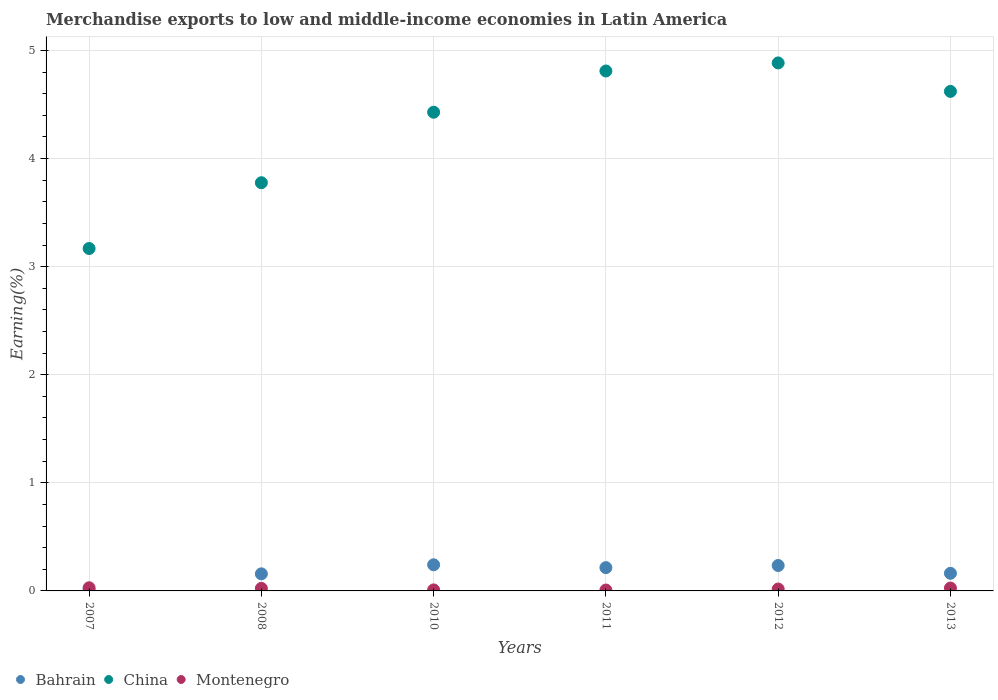What is the percentage of amount earned from merchandise exports in China in 2013?
Your answer should be very brief. 4.62. Across all years, what is the maximum percentage of amount earned from merchandise exports in China?
Make the answer very short. 4.88. Across all years, what is the minimum percentage of amount earned from merchandise exports in China?
Offer a terse response. 3.17. What is the total percentage of amount earned from merchandise exports in China in the graph?
Provide a short and direct response. 25.69. What is the difference between the percentage of amount earned from merchandise exports in Montenegro in 2010 and that in 2011?
Offer a terse response. 0. What is the difference between the percentage of amount earned from merchandise exports in Montenegro in 2011 and the percentage of amount earned from merchandise exports in Bahrain in 2013?
Provide a short and direct response. -0.15. What is the average percentage of amount earned from merchandise exports in Montenegro per year?
Offer a very short reply. 0.02. In the year 2011, what is the difference between the percentage of amount earned from merchandise exports in Montenegro and percentage of amount earned from merchandise exports in China?
Offer a very short reply. -4.8. What is the ratio of the percentage of amount earned from merchandise exports in China in 2008 to that in 2012?
Provide a short and direct response. 0.77. What is the difference between the highest and the second highest percentage of amount earned from merchandise exports in Bahrain?
Provide a short and direct response. 0.01. What is the difference between the highest and the lowest percentage of amount earned from merchandise exports in Bahrain?
Your answer should be compact. 0.23. In how many years, is the percentage of amount earned from merchandise exports in China greater than the average percentage of amount earned from merchandise exports in China taken over all years?
Give a very brief answer. 4. Is the sum of the percentage of amount earned from merchandise exports in China in 2007 and 2011 greater than the maximum percentage of amount earned from merchandise exports in Bahrain across all years?
Provide a short and direct response. Yes. Does the percentage of amount earned from merchandise exports in Montenegro monotonically increase over the years?
Provide a short and direct response. No. Is the percentage of amount earned from merchandise exports in China strictly less than the percentage of amount earned from merchandise exports in Bahrain over the years?
Ensure brevity in your answer.  No. How many years are there in the graph?
Your answer should be very brief. 6. What is the difference between two consecutive major ticks on the Y-axis?
Your response must be concise. 1. Does the graph contain grids?
Ensure brevity in your answer.  Yes. How many legend labels are there?
Offer a terse response. 3. How are the legend labels stacked?
Your answer should be compact. Horizontal. What is the title of the graph?
Your answer should be very brief. Merchandise exports to low and middle-income economies in Latin America. Does "Israel" appear as one of the legend labels in the graph?
Offer a terse response. No. What is the label or title of the X-axis?
Your response must be concise. Years. What is the label or title of the Y-axis?
Keep it short and to the point. Earning(%). What is the Earning(%) of Bahrain in 2007?
Give a very brief answer. 0.01. What is the Earning(%) of China in 2007?
Keep it short and to the point. 3.17. What is the Earning(%) of Montenegro in 2007?
Offer a very short reply. 0.03. What is the Earning(%) of Bahrain in 2008?
Offer a terse response. 0.16. What is the Earning(%) in China in 2008?
Keep it short and to the point. 3.78. What is the Earning(%) of Montenegro in 2008?
Ensure brevity in your answer.  0.02. What is the Earning(%) in Bahrain in 2010?
Provide a short and direct response. 0.24. What is the Earning(%) in China in 2010?
Keep it short and to the point. 4.43. What is the Earning(%) of Montenegro in 2010?
Offer a terse response. 0.01. What is the Earning(%) of Bahrain in 2011?
Give a very brief answer. 0.22. What is the Earning(%) in China in 2011?
Keep it short and to the point. 4.81. What is the Earning(%) in Montenegro in 2011?
Your answer should be very brief. 0.01. What is the Earning(%) in Bahrain in 2012?
Make the answer very short. 0.24. What is the Earning(%) in China in 2012?
Your answer should be compact. 4.88. What is the Earning(%) in Montenegro in 2012?
Your response must be concise. 0.02. What is the Earning(%) of Bahrain in 2013?
Your answer should be very brief. 0.16. What is the Earning(%) of China in 2013?
Provide a short and direct response. 4.62. What is the Earning(%) in Montenegro in 2013?
Provide a succinct answer. 0.03. Across all years, what is the maximum Earning(%) in Bahrain?
Offer a very short reply. 0.24. Across all years, what is the maximum Earning(%) in China?
Make the answer very short. 4.88. Across all years, what is the maximum Earning(%) in Montenegro?
Provide a short and direct response. 0.03. Across all years, what is the minimum Earning(%) in Bahrain?
Make the answer very short. 0.01. Across all years, what is the minimum Earning(%) of China?
Give a very brief answer. 3.17. Across all years, what is the minimum Earning(%) in Montenegro?
Give a very brief answer. 0.01. What is the total Earning(%) of Bahrain in the graph?
Ensure brevity in your answer.  1.02. What is the total Earning(%) of China in the graph?
Offer a terse response. 25.69. What is the total Earning(%) in Montenegro in the graph?
Ensure brevity in your answer.  0.11. What is the difference between the Earning(%) in Bahrain in 2007 and that in 2008?
Provide a succinct answer. -0.15. What is the difference between the Earning(%) of China in 2007 and that in 2008?
Your answer should be very brief. -0.61. What is the difference between the Earning(%) in Montenegro in 2007 and that in 2008?
Your response must be concise. 0.01. What is the difference between the Earning(%) in Bahrain in 2007 and that in 2010?
Give a very brief answer. -0.23. What is the difference between the Earning(%) in China in 2007 and that in 2010?
Your answer should be very brief. -1.26. What is the difference between the Earning(%) of Montenegro in 2007 and that in 2010?
Give a very brief answer. 0.02. What is the difference between the Earning(%) in Bahrain in 2007 and that in 2011?
Your response must be concise. -0.21. What is the difference between the Earning(%) of China in 2007 and that in 2011?
Make the answer very short. -1.64. What is the difference between the Earning(%) of Montenegro in 2007 and that in 2011?
Ensure brevity in your answer.  0.02. What is the difference between the Earning(%) of Bahrain in 2007 and that in 2012?
Provide a succinct answer. -0.23. What is the difference between the Earning(%) of China in 2007 and that in 2012?
Give a very brief answer. -1.72. What is the difference between the Earning(%) in Montenegro in 2007 and that in 2012?
Offer a terse response. 0.01. What is the difference between the Earning(%) in Bahrain in 2007 and that in 2013?
Offer a terse response. -0.15. What is the difference between the Earning(%) of China in 2007 and that in 2013?
Ensure brevity in your answer.  -1.45. What is the difference between the Earning(%) in Montenegro in 2007 and that in 2013?
Offer a very short reply. 0. What is the difference between the Earning(%) of Bahrain in 2008 and that in 2010?
Keep it short and to the point. -0.08. What is the difference between the Earning(%) of China in 2008 and that in 2010?
Make the answer very short. -0.65. What is the difference between the Earning(%) in Montenegro in 2008 and that in 2010?
Provide a short and direct response. 0.01. What is the difference between the Earning(%) of Bahrain in 2008 and that in 2011?
Keep it short and to the point. -0.06. What is the difference between the Earning(%) in China in 2008 and that in 2011?
Provide a short and direct response. -1.03. What is the difference between the Earning(%) of Montenegro in 2008 and that in 2011?
Keep it short and to the point. 0.02. What is the difference between the Earning(%) of Bahrain in 2008 and that in 2012?
Ensure brevity in your answer.  -0.08. What is the difference between the Earning(%) of China in 2008 and that in 2012?
Make the answer very short. -1.11. What is the difference between the Earning(%) in Montenegro in 2008 and that in 2012?
Offer a terse response. 0.01. What is the difference between the Earning(%) in Bahrain in 2008 and that in 2013?
Provide a succinct answer. -0.01. What is the difference between the Earning(%) in China in 2008 and that in 2013?
Offer a terse response. -0.84. What is the difference between the Earning(%) in Montenegro in 2008 and that in 2013?
Your answer should be compact. -0. What is the difference between the Earning(%) of Bahrain in 2010 and that in 2011?
Keep it short and to the point. 0.03. What is the difference between the Earning(%) of China in 2010 and that in 2011?
Make the answer very short. -0.38. What is the difference between the Earning(%) in Montenegro in 2010 and that in 2011?
Offer a terse response. 0. What is the difference between the Earning(%) of Bahrain in 2010 and that in 2012?
Provide a short and direct response. 0.01. What is the difference between the Earning(%) of China in 2010 and that in 2012?
Your answer should be very brief. -0.46. What is the difference between the Earning(%) in Montenegro in 2010 and that in 2012?
Give a very brief answer. -0.01. What is the difference between the Earning(%) of Bahrain in 2010 and that in 2013?
Offer a terse response. 0.08. What is the difference between the Earning(%) of China in 2010 and that in 2013?
Keep it short and to the point. -0.19. What is the difference between the Earning(%) of Montenegro in 2010 and that in 2013?
Your answer should be very brief. -0.02. What is the difference between the Earning(%) in Bahrain in 2011 and that in 2012?
Keep it short and to the point. -0.02. What is the difference between the Earning(%) in China in 2011 and that in 2012?
Provide a short and direct response. -0.07. What is the difference between the Earning(%) in Montenegro in 2011 and that in 2012?
Your answer should be very brief. -0.01. What is the difference between the Earning(%) in Bahrain in 2011 and that in 2013?
Give a very brief answer. 0.05. What is the difference between the Earning(%) in China in 2011 and that in 2013?
Ensure brevity in your answer.  0.19. What is the difference between the Earning(%) in Montenegro in 2011 and that in 2013?
Make the answer very short. -0.02. What is the difference between the Earning(%) in Bahrain in 2012 and that in 2013?
Offer a very short reply. 0.07. What is the difference between the Earning(%) of China in 2012 and that in 2013?
Offer a terse response. 0.26. What is the difference between the Earning(%) in Montenegro in 2012 and that in 2013?
Offer a very short reply. -0.01. What is the difference between the Earning(%) in Bahrain in 2007 and the Earning(%) in China in 2008?
Your answer should be very brief. -3.77. What is the difference between the Earning(%) in Bahrain in 2007 and the Earning(%) in Montenegro in 2008?
Make the answer very short. -0.02. What is the difference between the Earning(%) in China in 2007 and the Earning(%) in Montenegro in 2008?
Your answer should be compact. 3.14. What is the difference between the Earning(%) of Bahrain in 2007 and the Earning(%) of China in 2010?
Offer a very short reply. -4.42. What is the difference between the Earning(%) in Bahrain in 2007 and the Earning(%) in Montenegro in 2010?
Your response must be concise. -0. What is the difference between the Earning(%) in China in 2007 and the Earning(%) in Montenegro in 2010?
Ensure brevity in your answer.  3.16. What is the difference between the Earning(%) in Bahrain in 2007 and the Earning(%) in China in 2011?
Give a very brief answer. -4.8. What is the difference between the Earning(%) of Bahrain in 2007 and the Earning(%) of Montenegro in 2011?
Your response must be concise. -0. What is the difference between the Earning(%) in China in 2007 and the Earning(%) in Montenegro in 2011?
Offer a terse response. 3.16. What is the difference between the Earning(%) in Bahrain in 2007 and the Earning(%) in China in 2012?
Provide a short and direct response. -4.88. What is the difference between the Earning(%) of Bahrain in 2007 and the Earning(%) of Montenegro in 2012?
Keep it short and to the point. -0.01. What is the difference between the Earning(%) of China in 2007 and the Earning(%) of Montenegro in 2012?
Your answer should be very brief. 3.15. What is the difference between the Earning(%) in Bahrain in 2007 and the Earning(%) in China in 2013?
Offer a very short reply. -4.61. What is the difference between the Earning(%) in Bahrain in 2007 and the Earning(%) in Montenegro in 2013?
Give a very brief answer. -0.02. What is the difference between the Earning(%) of China in 2007 and the Earning(%) of Montenegro in 2013?
Your response must be concise. 3.14. What is the difference between the Earning(%) of Bahrain in 2008 and the Earning(%) of China in 2010?
Provide a short and direct response. -4.27. What is the difference between the Earning(%) in Bahrain in 2008 and the Earning(%) in Montenegro in 2010?
Provide a succinct answer. 0.15. What is the difference between the Earning(%) in China in 2008 and the Earning(%) in Montenegro in 2010?
Offer a very short reply. 3.77. What is the difference between the Earning(%) of Bahrain in 2008 and the Earning(%) of China in 2011?
Ensure brevity in your answer.  -4.65. What is the difference between the Earning(%) of Bahrain in 2008 and the Earning(%) of Montenegro in 2011?
Provide a succinct answer. 0.15. What is the difference between the Earning(%) in China in 2008 and the Earning(%) in Montenegro in 2011?
Offer a terse response. 3.77. What is the difference between the Earning(%) in Bahrain in 2008 and the Earning(%) in China in 2012?
Make the answer very short. -4.73. What is the difference between the Earning(%) of Bahrain in 2008 and the Earning(%) of Montenegro in 2012?
Your answer should be compact. 0.14. What is the difference between the Earning(%) in China in 2008 and the Earning(%) in Montenegro in 2012?
Give a very brief answer. 3.76. What is the difference between the Earning(%) of Bahrain in 2008 and the Earning(%) of China in 2013?
Your answer should be very brief. -4.46. What is the difference between the Earning(%) in Bahrain in 2008 and the Earning(%) in Montenegro in 2013?
Your response must be concise. 0.13. What is the difference between the Earning(%) in China in 2008 and the Earning(%) in Montenegro in 2013?
Your answer should be compact. 3.75. What is the difference between the Earning(%) of Bahrain in 2010 and the Earning(%) of China in 2011?
Provide a short and direct response. -4.57. What is the difference between the Earning(%) of Bahrain in 2010 and the Earning(%) of Montenegro in 2011?
Provide a succinct answer. 0.23. What is the difference between the Earning(%) of China in 2010 and the Earning(%) of Montenegro in 2011?
Provide a short and direct response. 4.42. What is the difference between the Earning(%) in Bahrain in 2010 and the Earning(%) in China in 2012?
Make the answer very short. -4.64. What is the difference between the Earning(%) of Bahrain in 2010 and the Earning(%) of Montenegro in 2012?
Keep it short and to the point. 0.22. What is the difference between the Earning(%) in China in 2010 and the Earning(%) in Montenegro in 2012?
Your answer should be compact. 4.41. What is the difference between the Earning(%) of Bahrain in 2010 and the Earning(%) of China in 2013?
Make the answer very short. -4.38. What is the difference between the Earning(%) of Bahrain in 2010 and the Earning(%) of Montenegro in 2013?
Offer a terse response. 0.22. What is the difference between the Earning(%) of China in 2010 and the Earning(%) of Montenegro in 2013?
Give a very brief answer. 4.4. What is the difference between the Earning(%) of Bahrain in 2011 and the Earning(%) of China in 2012?
Make the answer very short. -4.67. What is the difference between the Earning(%) in Bahrain in 2011 and the Earning(%) in Montenegro in 2012?
Provide a short and direct response. 0.2. What is the difference between the Earning(%) of China in 2011 and the Earning(%) of Montenegro in 2012?
Your response must be concise. 4.79. What is the difference between the Earning(%) of Bahrain in 2011 and the Earning(%) of China in 2013?
Keep it short and to the point. -4.41. What is the difference between the Earning(%) of Bahrain in 2011 and the Earning(%) of Montenegro in 2013?
Offer a very short reply. 0.19. What is the difference between the Earning(%) in China in 2011 and the Earning(%) in Montenegro in 2013?
Your response must be concise. 4.78. What is the difference between the Earning(%) in Bahrain in 2012 and the Earning(%) in China in 2013?
Provide a short and direct response. -4.39. What is the difference between the Earning(%) in Bahrain in 2012 and the Earning(%) in Montenegro in 2013?
Provide a short and direct response. 0.21. What is the difference between the Earning(%) in China in 2012 and the Earning(%) in Montenegro in 2013?
Keep it short and to the point. 4.86. What is the average Earning(%) of Bahrain per year?
Offer a very short reply. 0.17. What is the average Earning(%) in China per year?
Ensure brevity in your answer.  4.28. What is the average Earning(%) in Montenegro per year?
Your answer should be compact. 0.02. In the year 2007, what is the difference between the Earning(%) in Bahrain and Earning(%) in China?
Offer a very short reply. -3.16. In the year 2007, what is the difference between the Earning(%) of Bahrain and Earning(%) of Montenegro?
Your answer should be compact. -0.02. In the year 2007, what is the difference between the Earning(%) in China and Earning(%) in Montenegro?
Keep it short and to the point. 3.14. In the year 2008, what is the difference between the Earning(%) in Bahrain and Earning(%) in China?
Offer a terse response. -3.62. In the year 2008, what is the difference between the Earning(%) in Bahrain and Earning(%) in Montenegro?
Provide a short and direct response. 0.13. In the year 2008, what is the difference between the Earning(%) of China and Earning(%) of Montenegro?
Keep it short and to the point. 3.75. In the year 2010, what is the difference between the Earning(%) in Bahrain and Earning(%) in China?
Your answer should be very brief. -4.19. In the year 2010, what is the difference between the Earning(%) of Bahrain and Earning(%) of Montenegro?
Make the answer very short. 0.23. In the year 2010, what is the difference between the Earning(%) in China and Earning(%) in Montenegro?
Offer a terse response. 4.42. In the year 2011, what is the difference between the Earning(%) of Bahrain and Earning(%) of China?
Your response must be concise. -4.59. In the year 2011, what is the difference between the Earning(%) of Bahrain and Earning(%) of Montenegro?
Make the answer very short. 0.21. In the year 2011, what is the difference between the Earning(%) of China and Earning(%) of Montenegro?
Give a very brief answer. 4.8. In the year 2012, what is the difference between the Earning(%) in Bahrain and Earning(%) in China?
Keep it short and to the point. -4.65. In the year 2012, what is the difference between the Earning(%) in Bahrain and Earning(%) in Montenegro?
Your answer should be compact. 0.22. In the year 2012, what is the difference between the Earning(%) of China and Earning(%) of Montenegro?
Your answer should be very brief. 4.87. In the year 2013, what is the difference between the Earning(%) of Bahrain and Earning(%) of China?
Provide a short and direct response. -4.46. In the year 2013, what is the difference between the Earning(%) of Bahrain and Earning(%) of Montenegro?
Offer a terse response. 0.14. In the year 2013, what is the difference between the Earning(%) of China and Earning(%) of Montenegro?
Give a very brief answer. 4.59. What is the ratio of the Earning(%) of Bahrain in 2007 to that in 2008?
Provide a short and direct response. 0.05. What is the ratio of the Earning(%) in China in 2007 to that in 2008?
Provide a succinct answer. 0.84. What is the ratio of the Earning(%) of Montenegro in 2007 to that in 2008?
Ensure brevity in your answer.  1.25. What is the ratio of the Earning(%) of Bahrain in 2007 to that in 2010?
Keep it short and to the point. 0.03. What is the ratio of the Earning(%) in China in 2007 to that in 2010?
Keep it short and to the point. 0.72. What is the ratio of the Earning(%) in Montenegro in 2007 to that in 2010?
Provide a short and direct response. 3.11. What is the ratio of the Earning(%) in Bahrain in 2007 to that in 2011?
Provide a succinct answer. 0.04. What is the ratio of the Earning(%) in China in 2007 to that in 2011?
Offer a terse response. 0.66. What is the ratio of the Earning(%) in Montenegro in 2007 to that in 2011?
Your response must be concise. 3.57. What is the ratio of the Earning(%) in Bahrain in 2007 to that in 2012?
Your answer should be very brief. 0.03. What is the ratio of the Earning(%) of China in 2007 to that in 2012?
Your answer should be very brief. 0.65. What is the ratio of the Earning(%) of Montenegro in 2007 to that in 2012?
Keep it short and to the point. 1.67. What is the ratio of the Earning(%) of Bahrain in 2007 to that in 2013?
Provide a succinct answer. 0.05. What is the ratio of the Earning(%) in China in 2007 to that in 2013?
Make the answer very short. 0.69. What is the ratio of the Earning(%) of Montenegro in 2007 to that in 2013?
Provide a succinct answer. 1.11. What is the ratio of the Earning(%) in Bahrain in 2008 to that in 2010?
Make the answer very short. 0.65. What is the ratio of the Earning(%) in China in 2008 to that in 2010?
Provide a short and direct response. 0.85. What is the ratio of the Earning(%) in Montenegro in 2008 to that in 2010?
Ensure brevity in your answer.  2.49. What is the ratio of the Earning(%) of Bahrain in 2008 to that in 2011?
Offer a very short reply. 0.73. What is the ratio of the Earning(%) of China in 2008 to that in 2011?
Your answer should be very brief. 0.79. What is the ratio of the Earning(%) of Montenegro in 2008 to that in 2011?
Make the answer very short. 2.87. What is the ratio of the Earning(%) in Bahrain in 2008 to that in 2012?
Your answer should be very brief. 0.67. What is the ratio of the Earning(%) in China in 2008 to that in 2012?
Provide a short and direct response. 0.77. What is the ratio of the Earning(%) of Montenegro in 2008 to that in 2012?
Provide a short and direct response. 1.34. What is the ratio of the Earning(%) in Bahrain in 2008 to that in 2013?
Provide a short and direct response. 0.97. What is the ratio of the Earning(%) of China in 2008 to that in 2013?
Ensure brevity in your answer.  0.82. What is the ratio of the Earning(%) in Montenegro in 2008 to that in 2013?
Give a very brief answer. 0.89. What is the ratio of the Earning(%) in Bahrain in 2010 to that in 2011?
Ensure brevity in your answer.  1.12. What is the ratio of the Earning(%) of China in 2010 to that in 2011?
Give a very brief answer. 0.92. What is the ratio of the Earning(%) in Montenegro in 2010 to that in 2011?
Offer a very short reply. 1.15. What is the ratio of the Earning(%) of Bahrain in 2010 to that in 2012?
Offer a terse response. 1.03. What is the ratio of the Earning(%) of China in 2010 to that in 2012?
Give a very brief answer. 0.91. What is the ratio of the Earning(%) of Montenegro in 2010 to that in 2012?
Ensure brevity in your answer.  0.54. What is the ratio of the Earning(%) of Bahrain in 2010 to that in 2013?
Provide a short and direct response. 1.48. What is the ratio of the Earning(%) in China in 2010 to that in 2013?
Your response must be concise. 0.96. What is the ratio of the Earning(%) of Montenegro in 2010 to that in 2013?
Make the answer very short. 0.36. What is the ratio of the Earning(%) of Bahrain in 2011 to that in 2012?
Provide a succinct answer. 0.92. What is the ratio of the Earning(%) of China in 2011 to that in 2012?
Provide a succinct answer. 0.98. What is the ratio of the Earning(%) in Montenegro in 2011 to that in 2012?
Provide a succinct answer. 0.47. What is the ratio of the Earning(%) of Bahrain in 2011 to that in 2013?
Your response must be concise. 1.32. What is the ratio of the Earning(%) in China in 2011 to that in 2013?
Keep it short and to the point. 1.04. What is the ratio of the Earning(%) in Montenegro in 2011 to that in 2013?
Offer a terse response. 0.31. What is the ratio of the Earning(%) in Bahrain in 2012 to that in 2013?
Provide a succinct answer. 1.44. What is the ratio of the Earning(%) in China in 2012 to that in 2013?
Ensure brevity in your answer.  1.06. What is the ratio of the Earning(%) of Montenegro in 2012 to that in 2013?
Ensure brevity in your answer.  0.66. What is the difference between the highest and the second highest Earning(%) of Bahrain?
Provide a short and direct response. 0.01. What is the difference between the highest and the second highest Earning(%) of China?
Your answer should be very brief. 0.07. What is the difference between the highest and the second highest Earning(%) in Montenegro?
Make the answer very short. 0. What is the difference between the highest and the lowest Earning(%) of Bahrain?
Your response must be concise. 0.23. What is the difference between the highest and the lowest Earning(%) in China?
Give a very brief answer. 1.72. What is the difference between the highest and the lowest Earning(%) in Montenegro?
Ensure brevity in your answer.  0.02. 